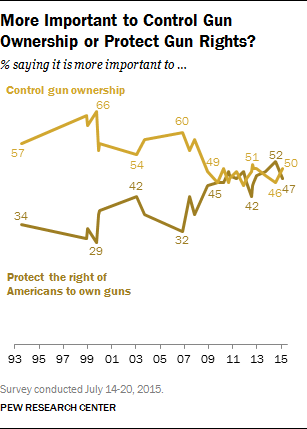What's the rightmost value dark brown graph?
 47 